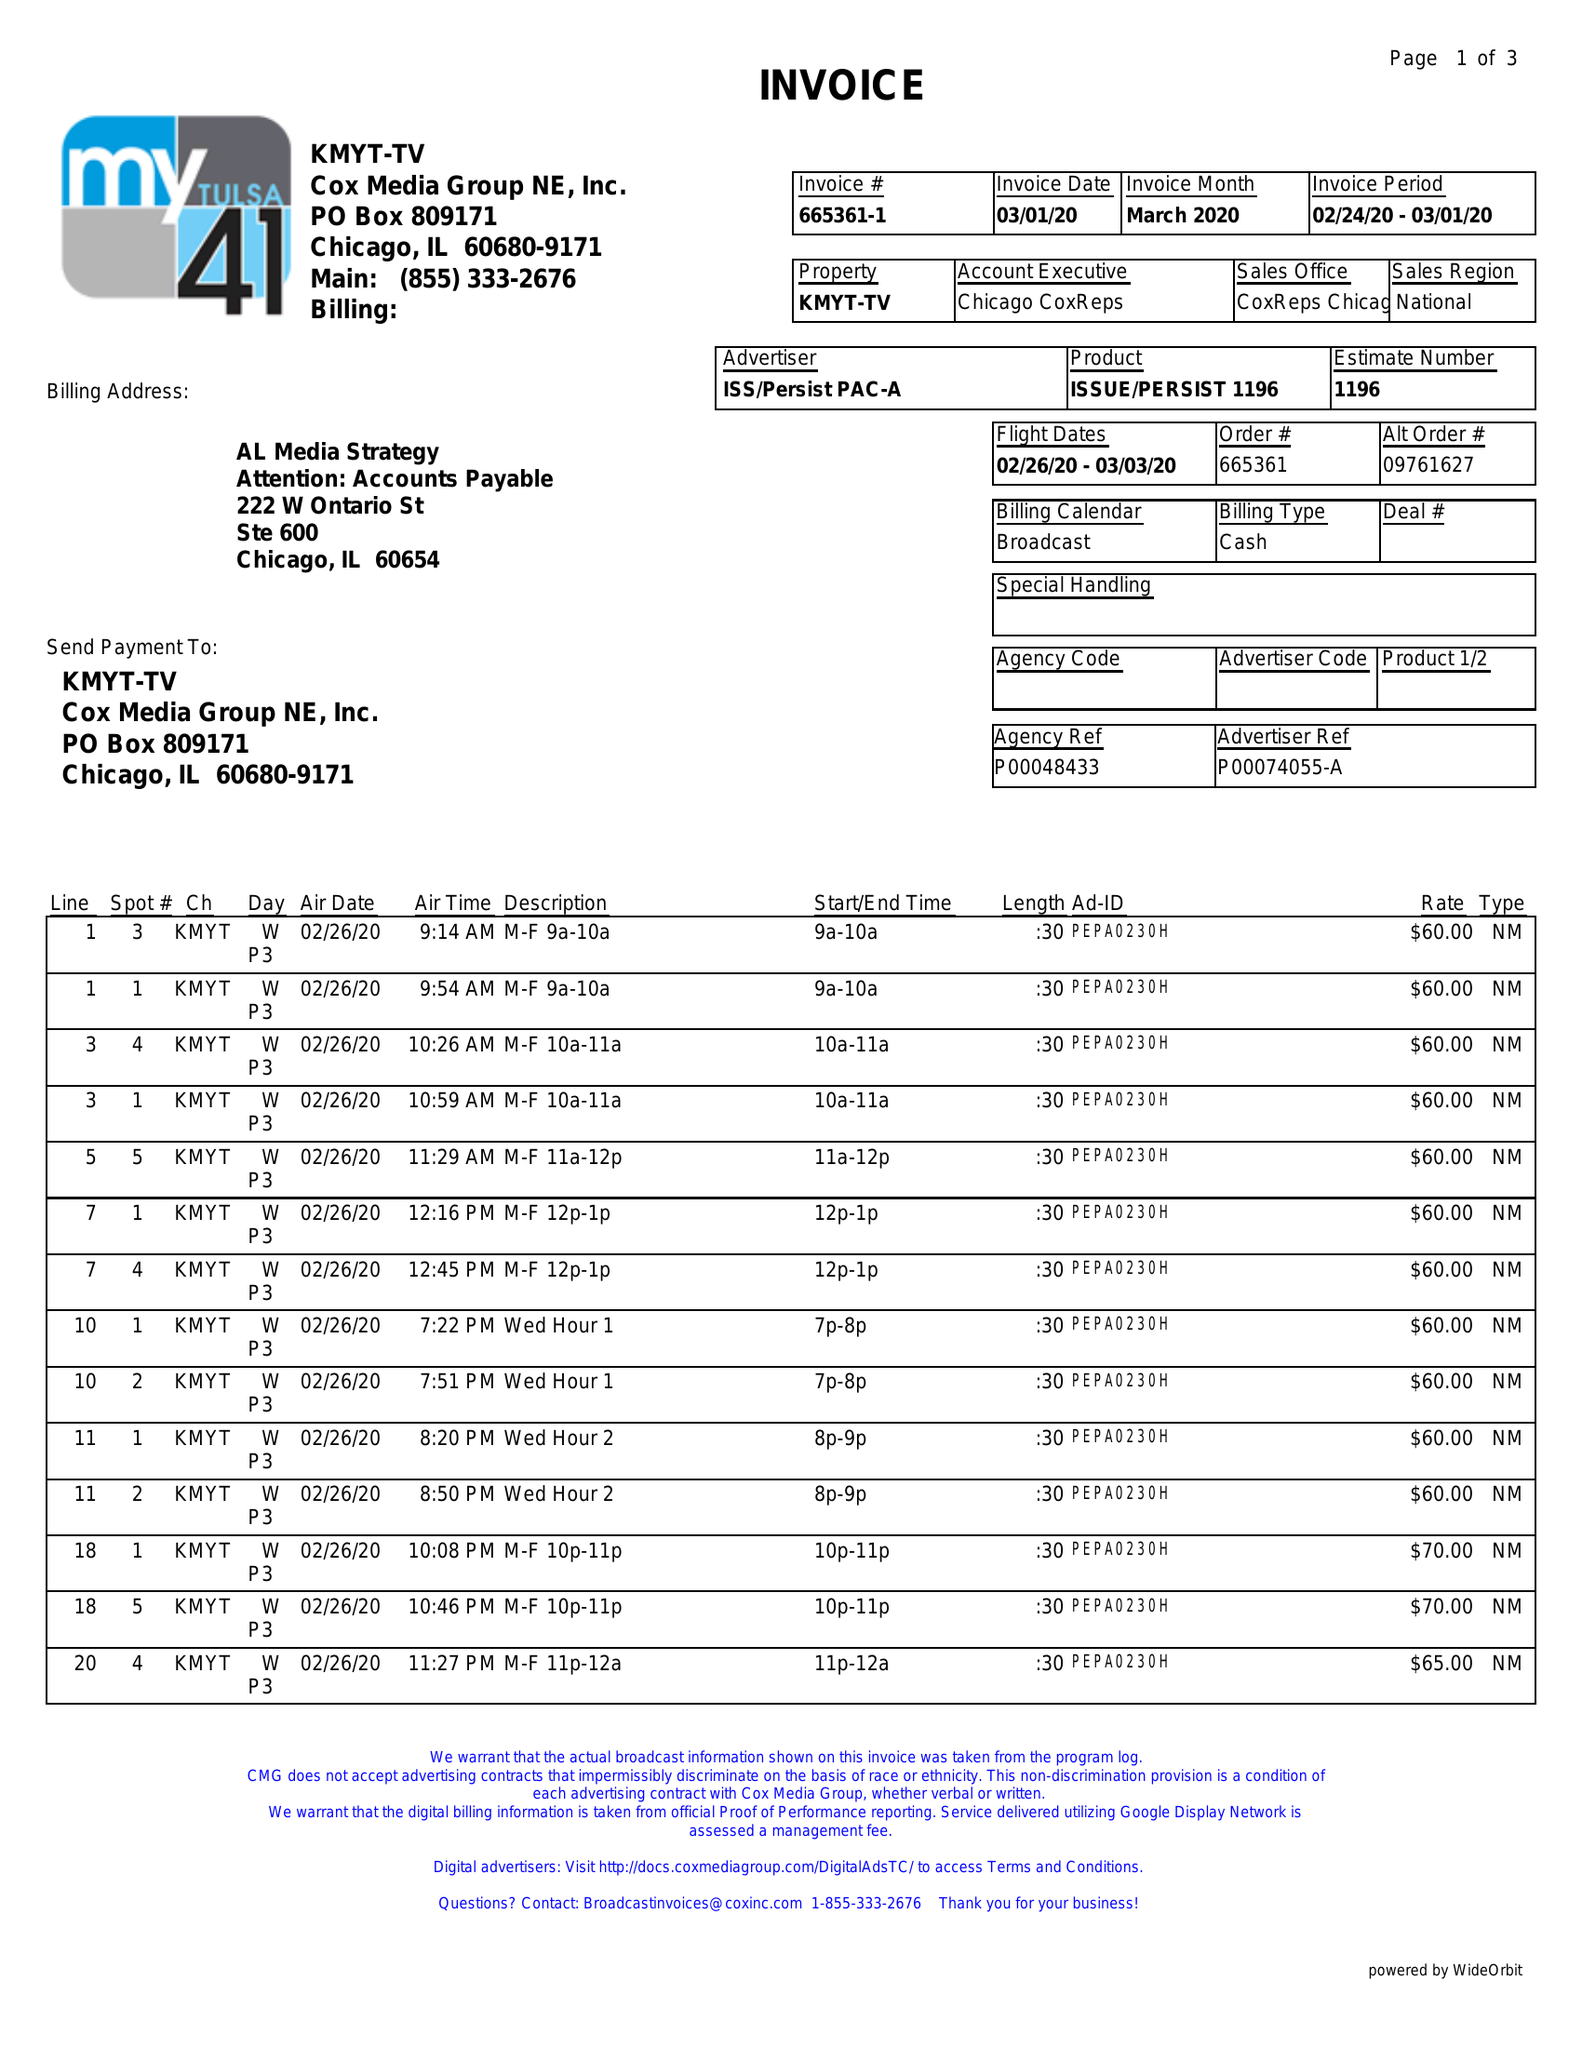What is the value for the contract_num?
Answer the question using a single word or phrase. 665361 